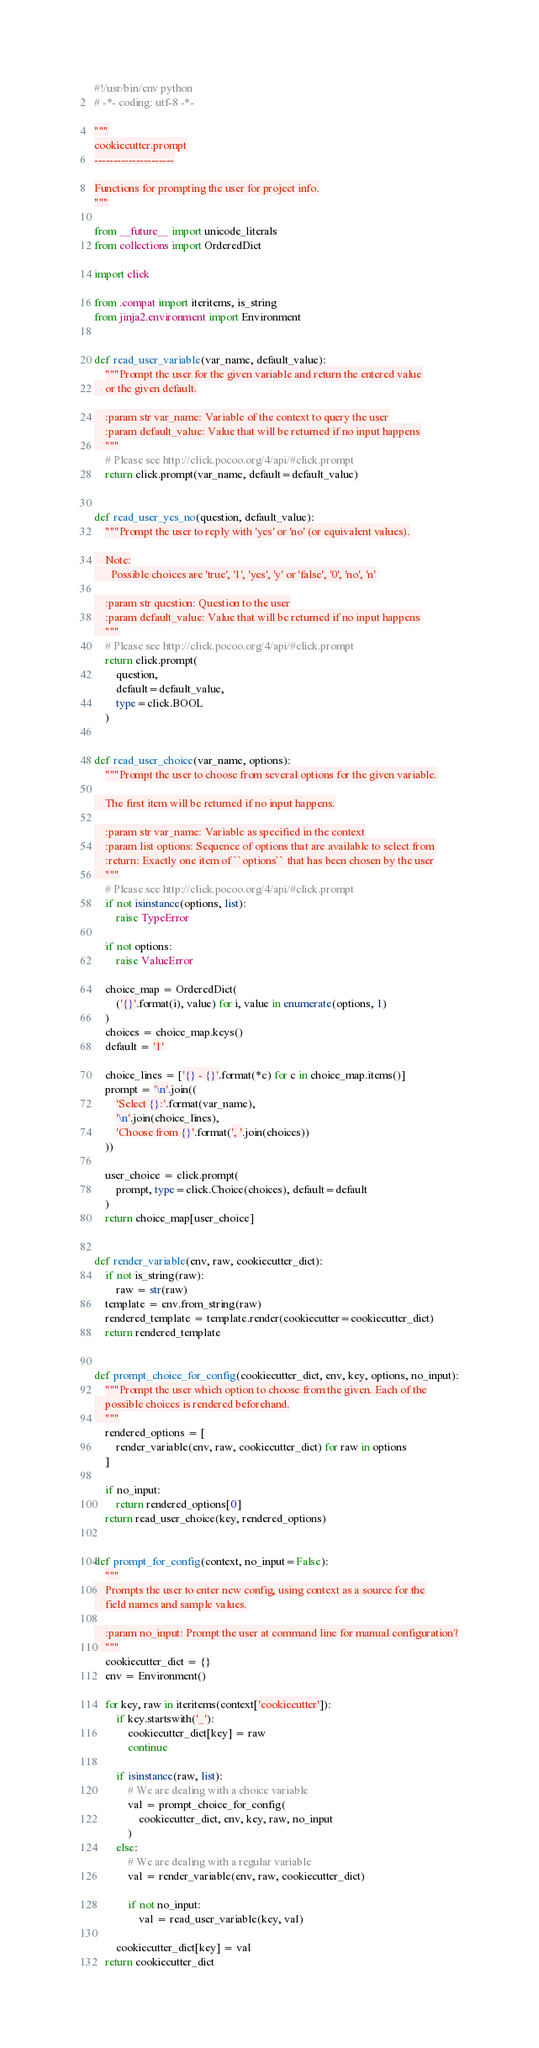Convert code to text. <code><loc_0><loc_0><loc_500><loc_500><_Python_>#!/usr/bin/env python
# -*- coding: utf-8 -*-

"""
cookiecutter.prompt
---------------------

Functions for prompting the user for project info.
"""

from __future__ import unicode_literals
from collections import OrderedDict

import click

from .compat import iteritems, is_string
from jinja2.environment import Environment


def read_user_variable(var_name, default_value):
    """Prompt the user for the given variable and return the entered value
    or the given default.

    :param str var_name: Variable of the context to query the user
    :param default_value: Value that will be returned if no input happens
    """
    # Please see http://click.pocoo.org/4/api/#click.prompt
    return click.prompt(var_name, default=default_value)


def read_user_yes_no(question, default_value):
    """Prompt the user to reply with 'yes' or 'no' (or equivalent values).

    Note:
      Possible choices are 'true', '1', 'yes', 'y' or 'false', '0', 'no', 'n'

    :param str question: Question to the user
    :param default_value: Value that will be returned if no input happens
    """
    # Please see http://click.pocoo.org/4/api/#click.prompt
    return click.prompt(
        question,
        default=default_value,
        type=click.BOOL
    )


def read_user_choice(var_name, options):
    """Prompt the user to choose from several options for the given variable.

    The first item will be returned if no input happens.

    :param str var_name: Variable as specified in the context
    :param list options: Sequence of options that are available to select from
    :return: Exactly one item of ``options`` that has been chosen by the user
    """
    # Please see http://click.pocoo.org/4/api/#click.prompt
    if not isinstance(options, list):
        raise TypeError

    if not options:
        raise ValueError

    choice_map = OrderedDict(
        ('{}'.format(i), value) for i, value in enumerate(options, 1)
    )
    choices = choice_map.keys()
    default = '1'

    choice_lines = ['{} - {}'.format(*c) for c in choice_map.items()]
    prompt = '\n'.join((
        'Select {}:'.format(var_name),
        '\n'.join(choice_lines),
        'Choose from {}'.format(', '.join(choices))
    ))

    user_choice = click.prompt(
        prompt, type=click.Choice(choices), default=default
    )
    return choice_map[user_choice]


def render_variable(env, raw, cookiecutter_dict):
    if not is_string(raw):
        raw = str(raw)
    template = env.from_string(raw)
    rendered_template = template.render(cookiecutter=cookiecutter_dict)
    return rendered_template


def prompt_choice_for_config(cookiecutter_dict, env, key, options, no_input):
    """Prompt the user which option to choose from the given. Each of the
    possible choices is rendered beforehand.
    """
    rendered_options = [
        render_variable(env, raw, cookiecutter_dict) for raw in options
    ]

    if no_input:
        return rendered_options[0]
    return read_user_choice(key, rendered_options)


def prompt_for_config(context, no_input=False):
    """
    Prompts the user to enter new config, using context as a source for the
    field names and sample values.

    :param no_input: Prompt the user at command line for manual configuration?
    """
    cookiecutter_dict = {}
    env = Environment()

    for key, raw in iteritems(context['cookiecutter']):
        if key.startswith('_'):
            cookiecutter_dict[key] = raw
            continue

        if isinstance(raw, list):
            # We are dealing with a choice variable
            val = prompt_choice_for_config(
                cookiecutter_dict, env, key, raw, no_input
            )
        else:
            # We are dealing with a regular variable
            val = render_variable(env, raw, cookiecutter_dict)

            if not no_input:
                val = read_user_variable(key, val)

        cookiecutter_dict[key] = val
    return cookiecutter_dict
</code> 